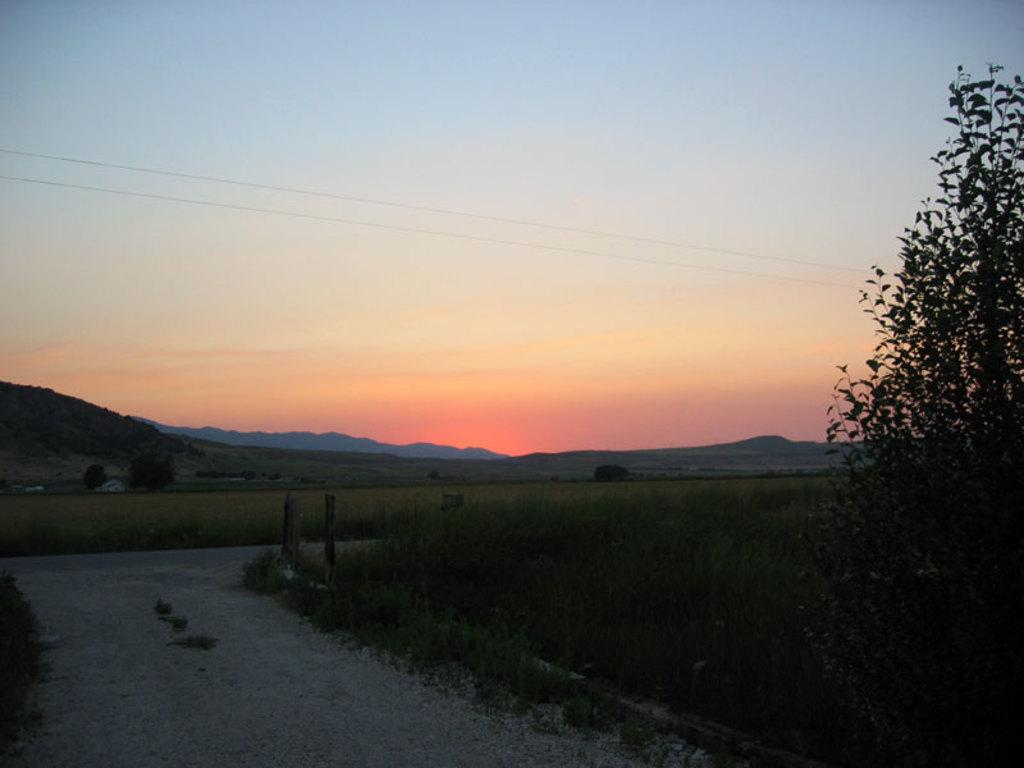What type of ground feature can be seen in the image? There is a pathway in the image. What type of vegetation is visible in the image? There are plants and trees visible in the image. What type of terrain is present in the image? The image contains hills. What part of the natural environment is visible in the image? The sky is visible in the image. What book is the person reading while standing on the hill in the image? There is no person or book present in the image; it only contains a pathway, plants, trees, hills, and the sky. 